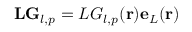<formula> <loc_0><loc_0><loc_500><loc_500>L G _ { l , p } = L G _ { l , p } ( r ) e _ { L } ( r )</formula> 